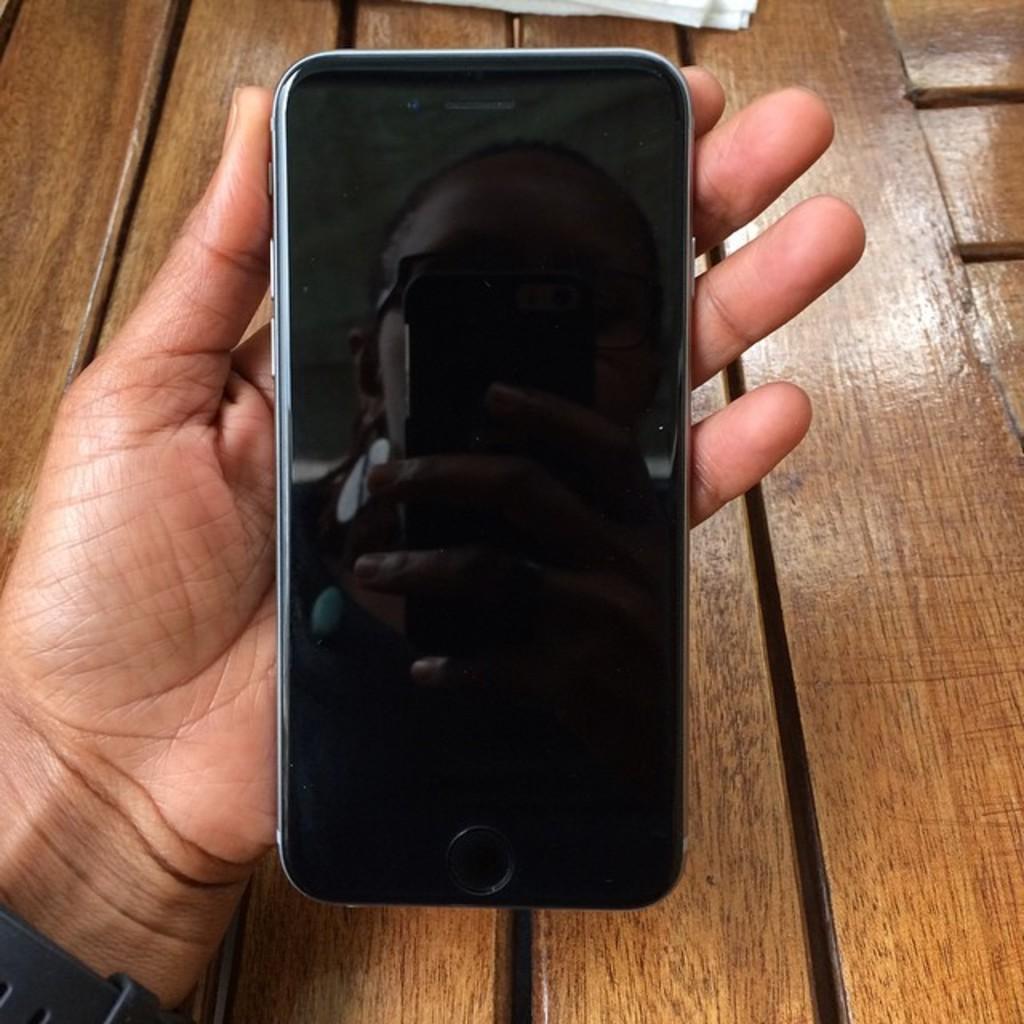Could you give a brief overview of what you see in this image? This is a zoomed in picture. In the center we can see the hand of a person, holding a mobile phone and on the screen of the mobile phone we can see the reflection of a person holding an object. In the background there is a wooden table. 